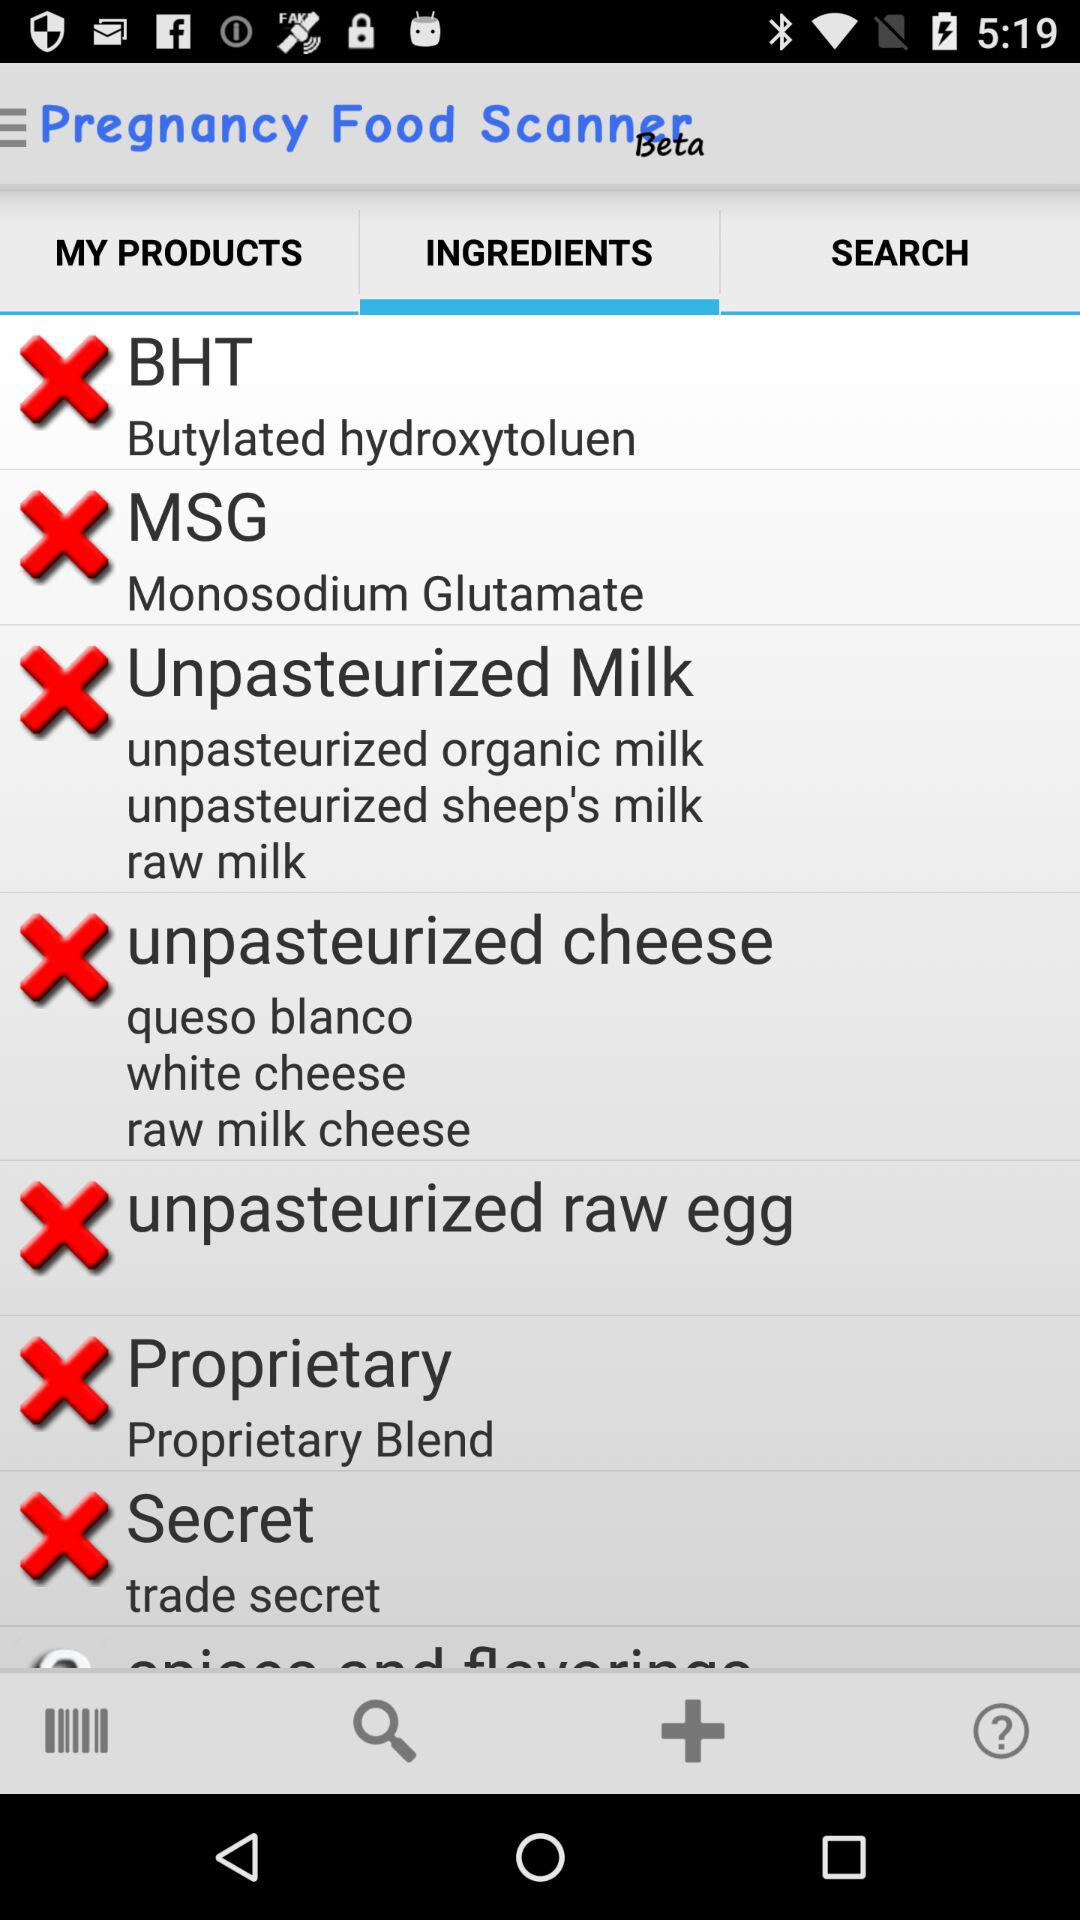Which tab is selected? The selected tab is ingredients. 